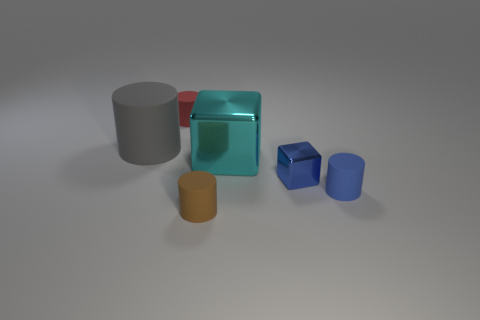Subtract all cyan blocks. How many blocks are left? 1 Subtract all red cylinders. How many cylinders are left? 3 Add 4 metallic blocks. How many objects exist? 10 Add 3 brown cylinders. How many brown cylinders are left? 4 Add 4 big green matte cylinders. How many big green matte cylinders exist? 4 Subtract 0 purple cylinders. How many objects are left? 6 Subtract all cubes. How many objects are left? 4 Subtract 1 cylinders. How many cylinders are left? 3 Subtract all blue cubes. Subtract all purple cylinders. How many cubes are left? 1 Subtract all green spheres. How many cyan blocks are left? 1 